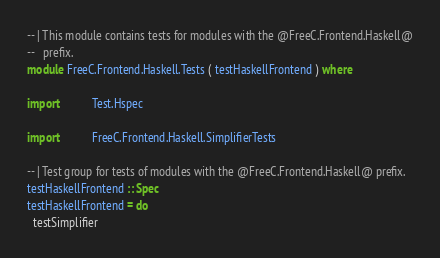<code> <loc_0><loc_0><loc_500><loc_500><_Haskell_>-- | This module contains tests for modules with the @FreeC.Frontend.Haskell@
--   prefix.
module FreeC.Frontend.Haskell.Tests ( testHaskellFrontend ) where

import           Test.Hspec

import           FreeC.Frontend.Haskell.SimplifierTests

-- | Test group for tests of modules with the @FreeC.Frontend.Haskell@ prefix.
testHaskellFrontend :: Spec
testHaskellFrontend = do
  testSimplifier
</code> 